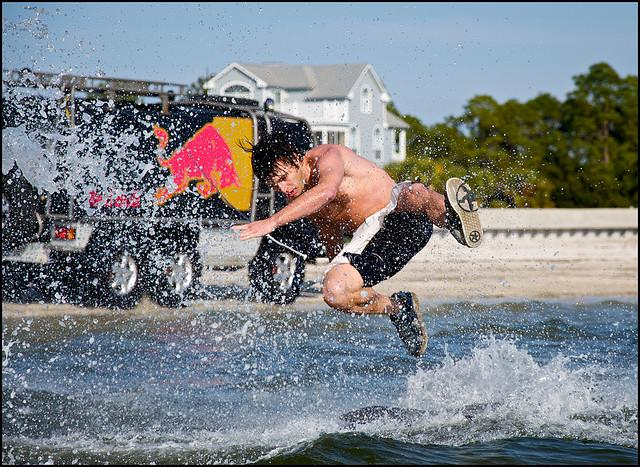What animal is the picture on the truck of?

Choices:
A) elephant
B) bull
C) condor
D) giraffe bull 